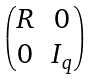<formula> <loc_0><loc_0><loc_500><loc_500>\begin{pmatrix} R & 0 \\ 0 & I _ { q } \end{pmatrix}</formula> 